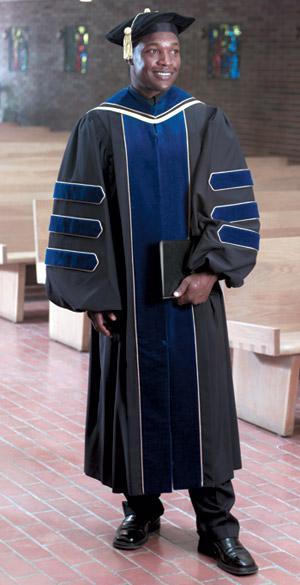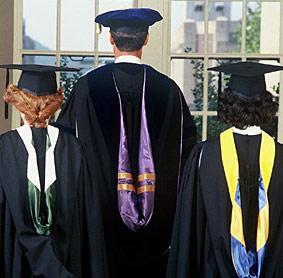The first image is the image on the left, the second image is the image on the right. Analyze the images presented: Is the assertion "There is one guy in the left image, wearing a black robe with blue stripes on the sleeve." valid? Answer yes or no. Yes. The first image is the image on the left, the second image is the image on the right. Analyze the images presented: Is the assertion "There is a single male with a blue and grey gown on in one image." valid? Answer yes or no. Yes. 